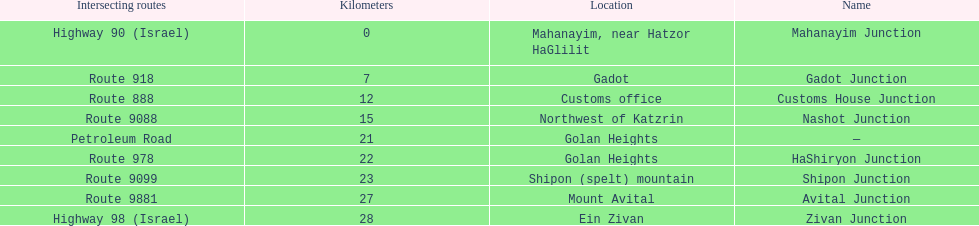Is nashot junction closer to shipon junction or avital junction? Shipon Junction. 